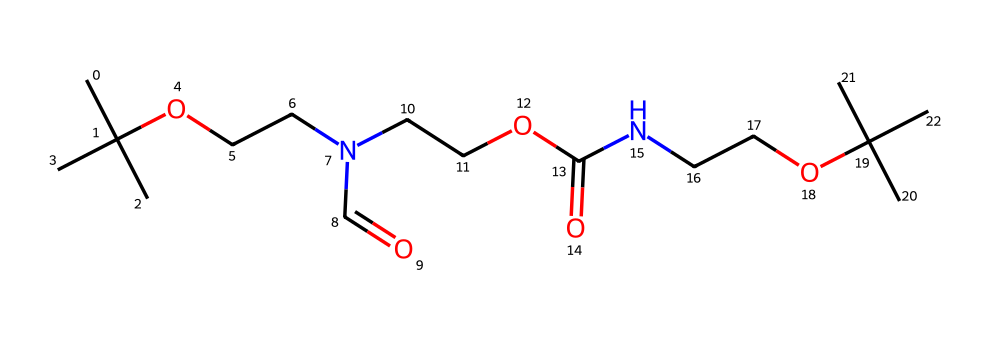What is the total number of carbon atoms in this chemical? By analyzing the SMILES representation, we can count the carbon (C) atoms present. Each upper-case "C" represents a carbon atom. In this structure, there are a total of 14 carbon atoms found.
Answer: 14 How many nitrogen atoms are present in this chemical? In the provided SMILES, each capital "N" represents a nitrogen atom. Scanning through the structure, we find there are 2 nitrogen atoms included.
Answer: 2 What type of functional groups are present in this chemical? The SMILES notation shows functional groups such as alkyl groups (represented by the branching and carbon arrangements), an amide group (indicated by "N(C=O)"), and ester groups (noted with "C(=O)O"). Thus, the chemical exhibits alkyl, amide, and ester functional groups.
Answer: alkyl, amide, ester Does this chemical contain any oxygen atoms? If so, how many? In the SMILES, oxygen is represented by the letter "O." By reviewing the structure, we find 4 oxygen atoms present in total within the molecule.
Answer: 4 What is the primary structure type of this chemical? The chemical structure reveals that it is primarily composed of a high molecular weight polymer due to the presence of various functional groups and branching patterns that are characteristic of plastics. Thus, it denotes a polymeric structure.
Answer: polymeric How many ester linkages can be found in this molecule? An ester linkage is characterized by a carbonyl (C=O) adjacent to an ether (C-O) connection. Analyzing the SMILES structure closely, we see there are 2 distinct points that indicate the presence of ester linkages.
Answer: 2 